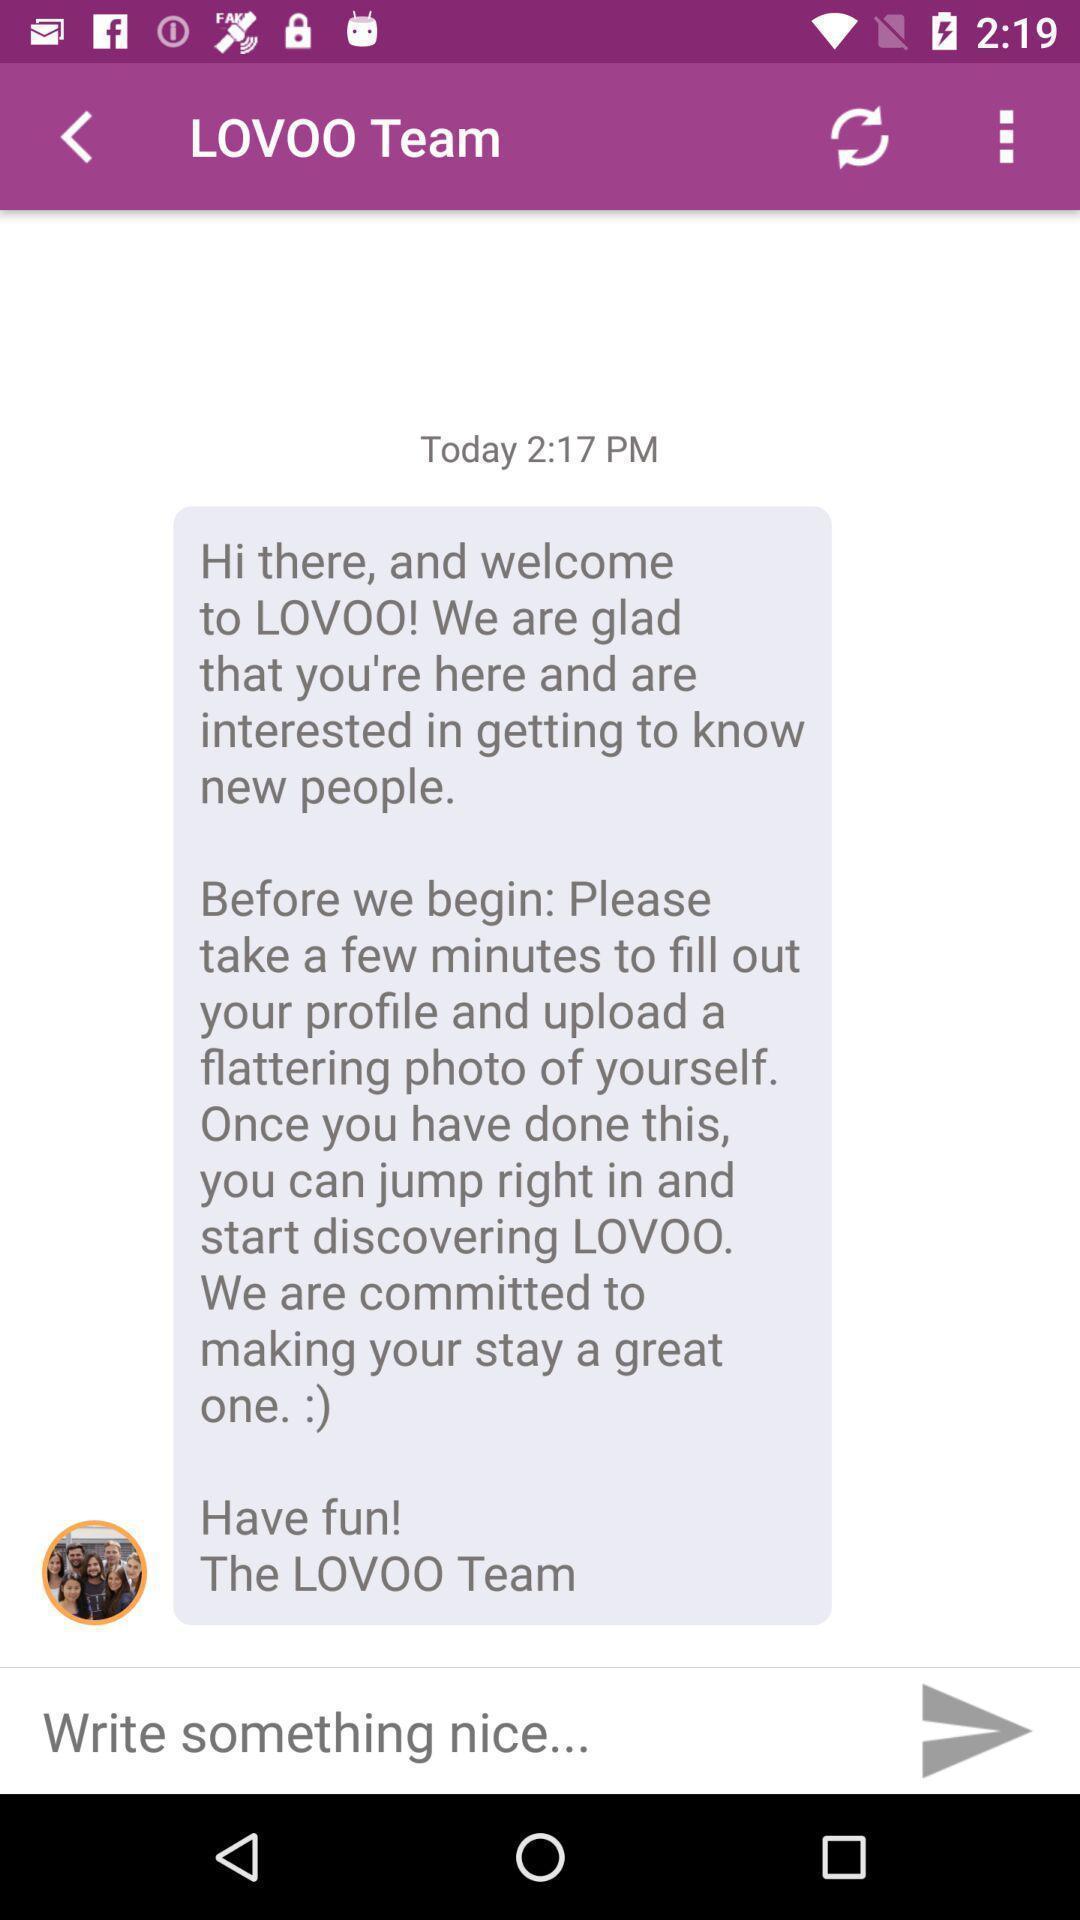Explain the elements present in this screenshot. Page showing chat box. 